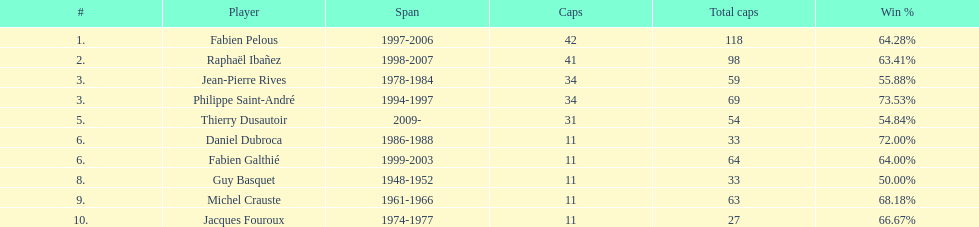How many caps did guy basquet accumulate throughout his career? 33. Give me the full table as a dictionary. {'header': ['#', 'Player', 'Span', 'Caps', 'Total caps', 'Win\xa0%'], 'rows': [['1.', 'Fabien Pelous', '1997-2006', '42', '118', '64.28%'], ['2.', 'Raphaël Ibañez', '1998-2007', '41', '98', '63.41%'], ['3.', 'Jean-Pierre Rives', '1978-1984', '34', '59', '55.88%'], ['3.', 'Philippe Saint-André', '1994-1997', '34', '69', '73.53%'], ['5.', 'Thierry Dusautoir', '2009-', '31', '54', '54.84%'], ['6.', 'Daniel Dubroca', '1986-1988', '11', '33', '72.00%'], ['6.', 'Fabien Galthié', '1999-2003', '11', '64', '64.00%'], ['8.', 'Guy Basquet', '1948-1952', '11', '33', '50.00%'], ['9.', 'Michel Crauste', '1961-1966', '11', '63', '68.18%'], ['10.', 'Jacques Fouroux', '1974-1977', '11', '27', '66.67%']]} 